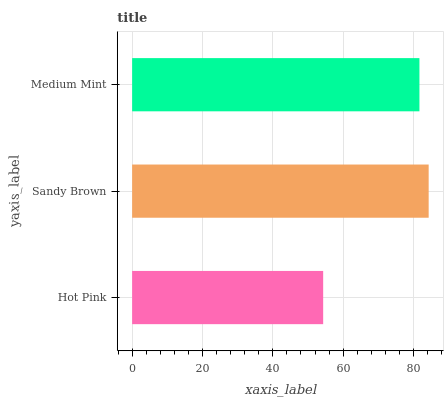Is Hot Pink the minimum?
Answer yes or no. Yes. Is Sandy Brown the maximum?
Answer yes or no. Yes. Is Medium Mint the minimum?
Answer yes or no. No. Is Medium Mint the maximum?
Answer yes or no. No. Is Sandy Brown greater than Medium Mint?
Answer yes or no. Yes. Is Medium Mint less than Sandy Brown?
Answer yes or no. Yes. Is Medium Mint greater than Sandy Brown?
Answer yes or no. No. Is Sandy Brown less than Medium Mint?
Answer yes or no. No. Is Medium Mint the high median?
Answer yes or no. Yes. Is Medium Mint the low median?
Answer yes or no. Yes. Is Hot Pink the high median?
Answer yes or no. No. Is Hot Pink the low median?
Answer yes or no. No. 